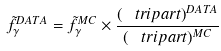Convert formula to latex. <formula><loc_0><loc_0><loc_500><loc_500>\tilde { f } ^ { D A T A } _ { \gamma } = \tilde { f } ^ { M C } _ { \gamma } \times \frac { ( \ t r i p a r t ) ^ { D A T A } } { ( \ t r i p a r t ) ^ { M C } }</formula> 